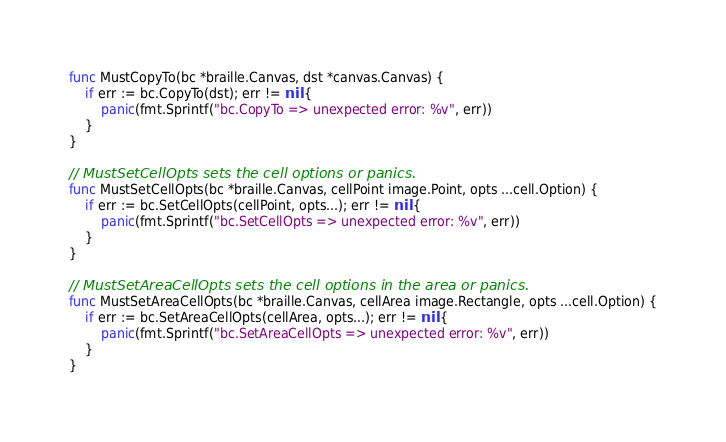<code> <loc_0><loc_0><loc_500><loc_500><_Go_>func MustCopyTo(bc *braille.Canvas, dst *canvas.Canvas) {
	if err := bc.CopyTo(dst); err != nil {
		panic(fmt.Sprintf("bc.CopyTo => unexpected error: %v", err))
	}
}

// MustSetCellOpts sets the cell options or panics.
func MustSetCellOpts(bc *braille.Canvas, cellPoint image.Point, opts ...cell.Option) {
	if err := bc.SetCellOpts(cellPoint, opts...); err != nil {
		panic(fmt.Sprintf("bc.SetCellOpts => unexpected error: %v", err))
	}
}

// MustSetAreaCellOpts sets the cell options in the area or panics.
func MustSetAreaCellOpts(bc *braille.Canvas, cellArea image.Rectangle, opts ...cell.Option) {
	if err := bc.SetAreaCellOpts(cellArea, opts...); err != nil {
		panic(fmt.Sprintf("bc.SetAreaCellOpts => unexpected error: %v", err))
	}
}
</code> 